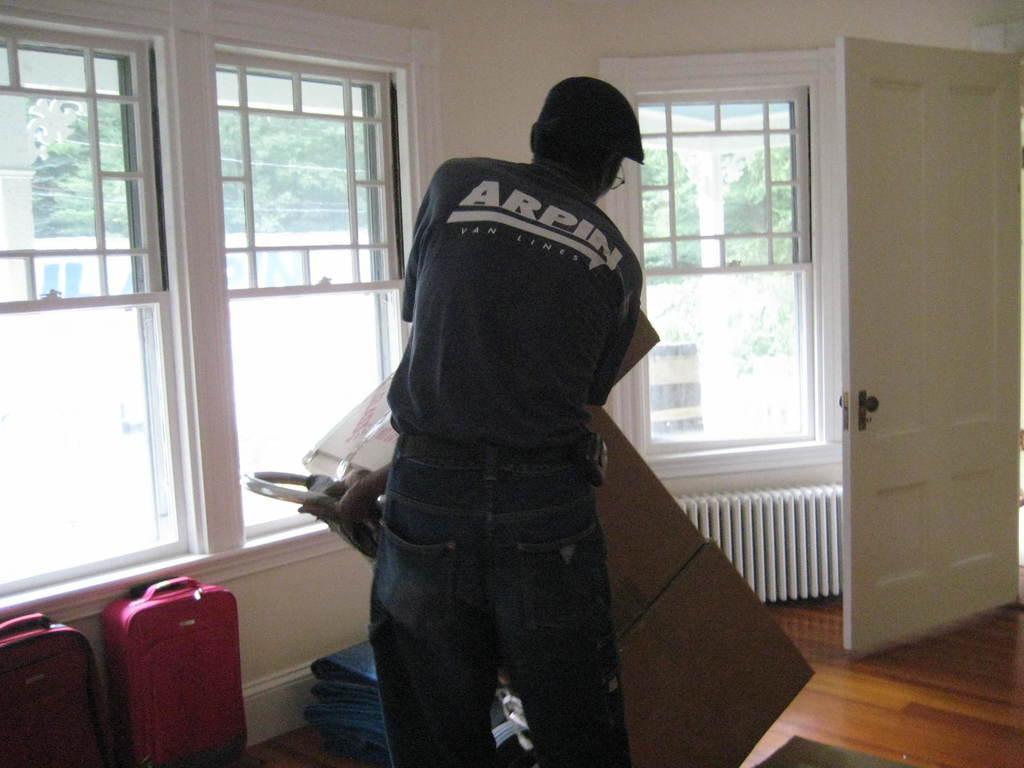Please provide a concise description of this image. A picture inside of a room. These are windows. This is door in white color. This man is standing and holding this cardboard boxes. The luggages are in red color. From this window we can able to see trees. 